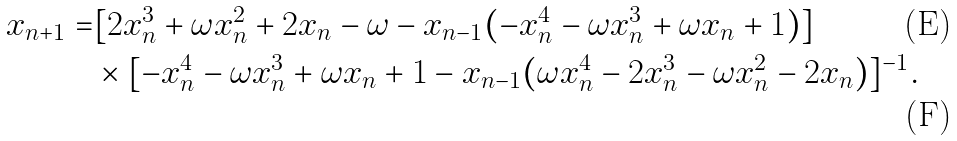Convert formula to latex. <formula><loc_0><loc_0><loc_500><loc_500>x _ { n + 1 } = & [ 2 x ^ { 3 } _ { n } + \omega x ^ { 2 } _ { n } + 2 x _ { n } - \omega - x _ { n - 1 } ( - x ^ { 4 } _ { n } - \omega x ^ { 3 } _ { n } + \omega x _ { n } + 1 ) ] \\ & \times [ - x ^ { 4 } _ { n } - \omega x ^ { 3 } _ { n } + \omega x _ { n } + 1 - x _ { n - 1 } ( \omega x ^ { 4 } _ { n } - 2 x ^ { 3 } _ { n } - \omega x ^ { 2 } _ { n } - 2 x _ { n } ) ] ^ { - 1 } .</formula> 